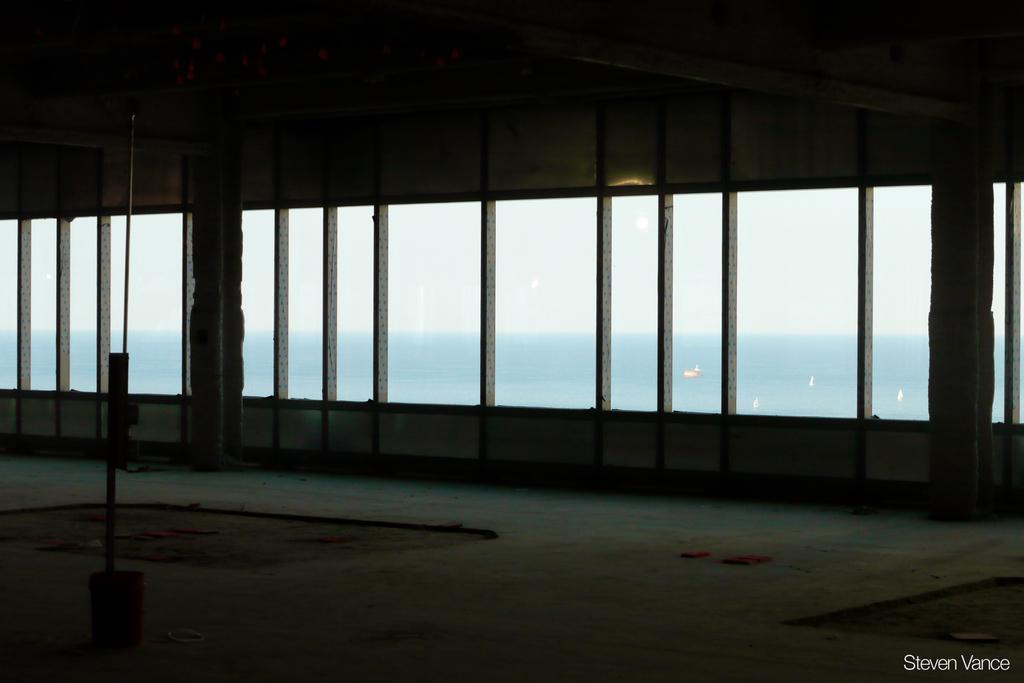Describe this image in one or two sentences. This is the inside picture of the building. In this image there is a pole. There are pillars. On top of the roof there are some objects. There are glass windows through which we can see boats in the water. In the background of the image there is sky. There is some text at the bottom of the image. 